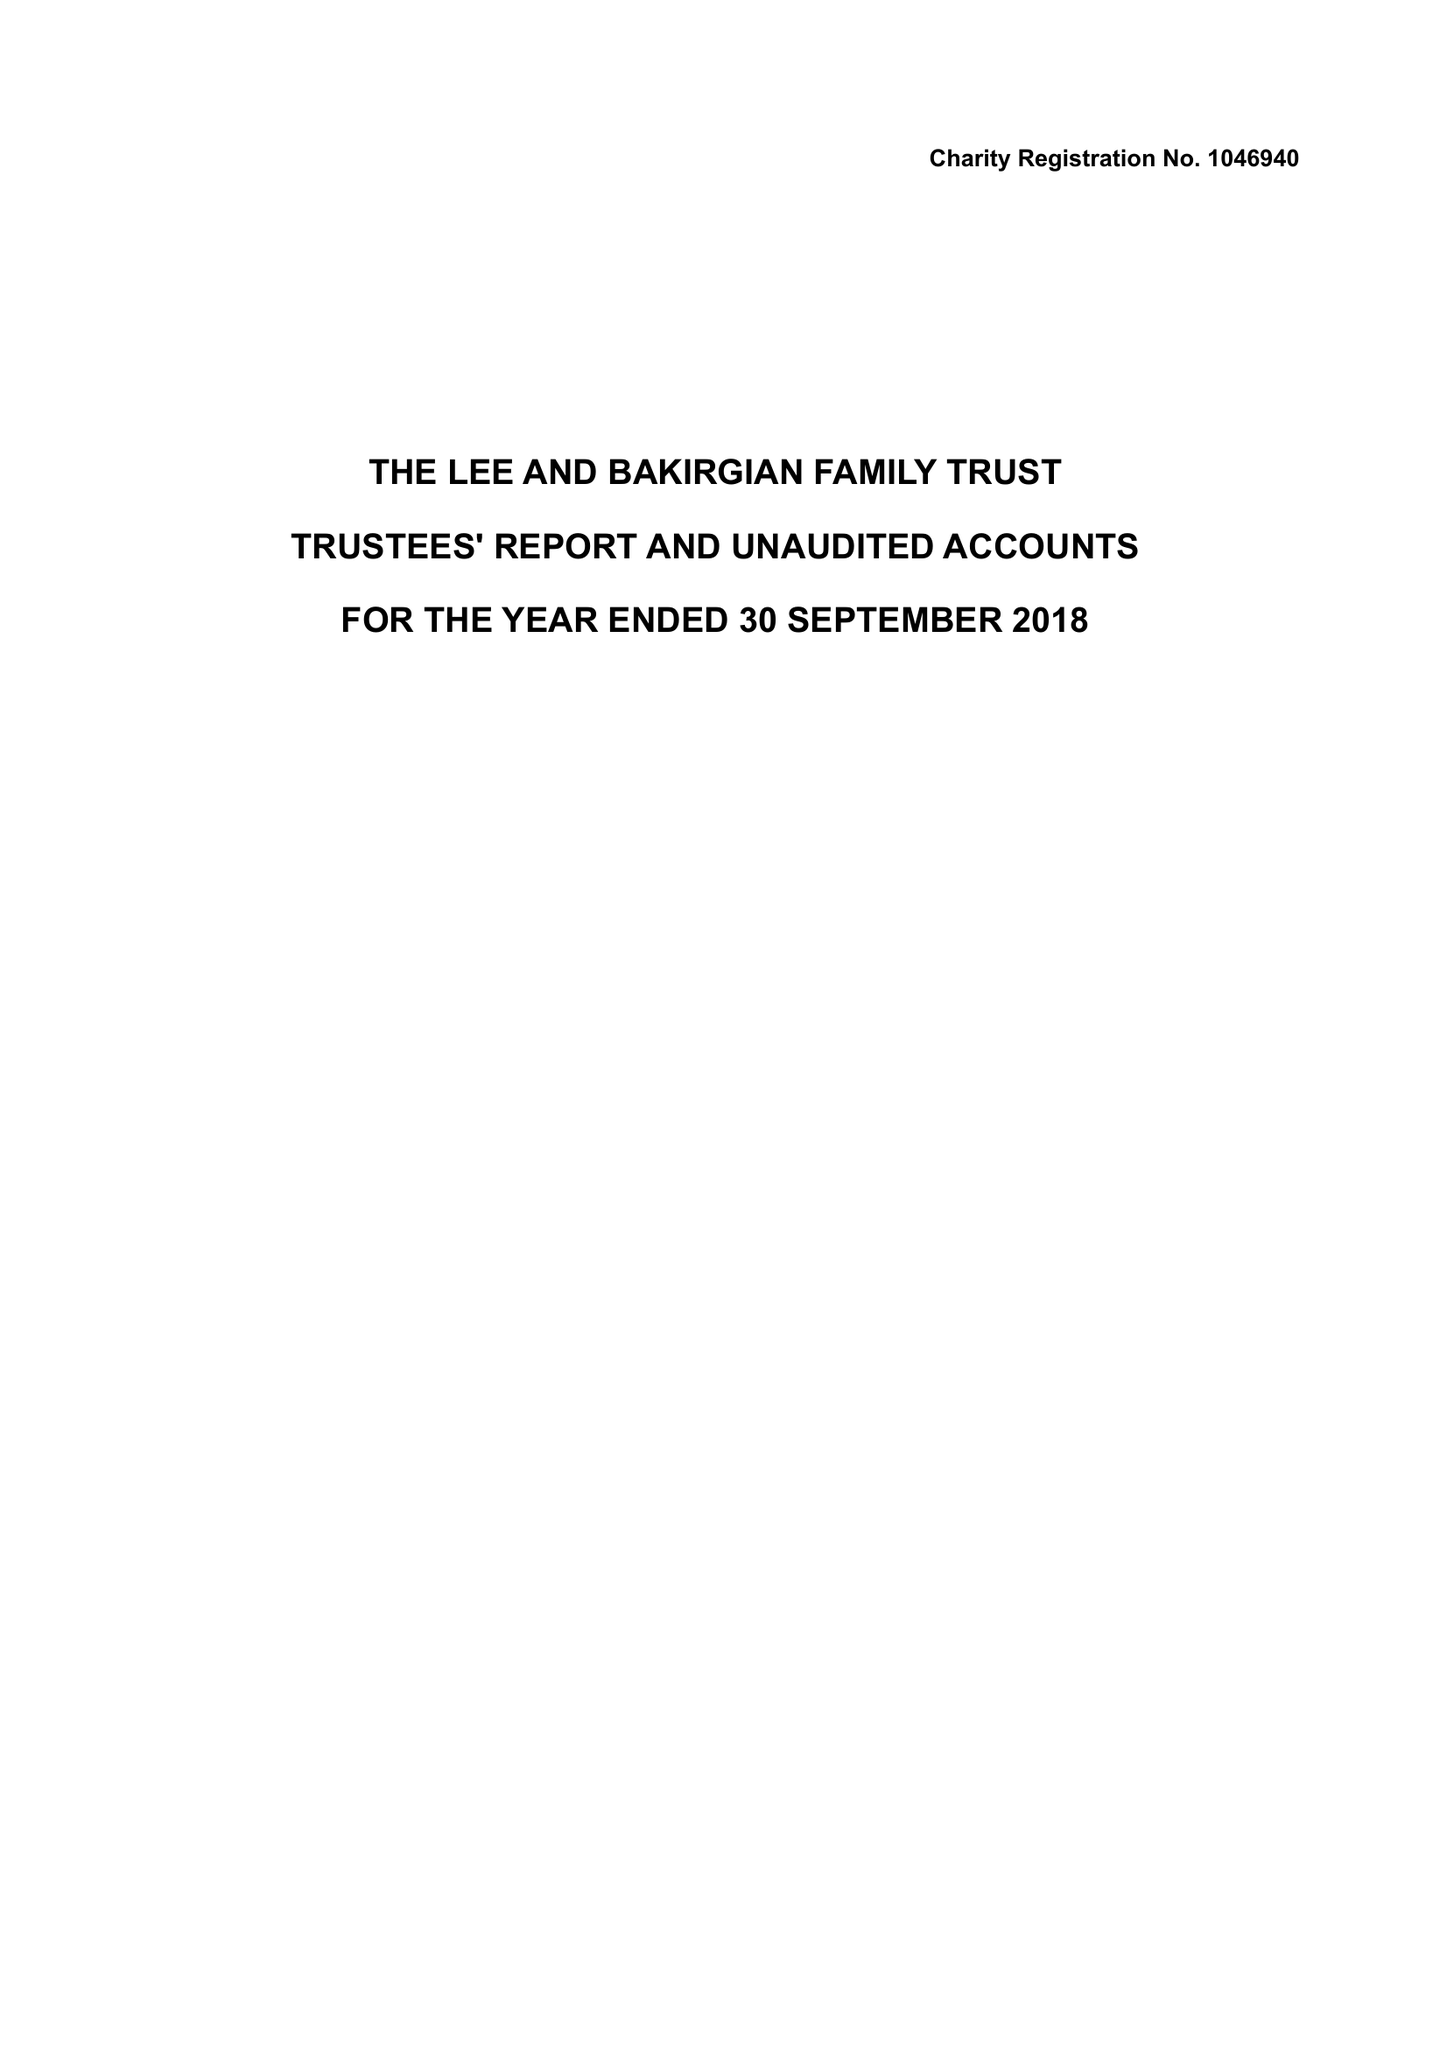What is the value for the address__post_town?
Answer the question using a single word or phrase. WARRINGTON 